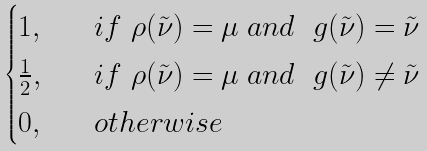<formula> <loc_0><loc_0><loc_500><loc_500>\begin{cases} 1 , \quad & i f \ \rho ( \tilde { \nu } ) = \mu \ a n d \ \ g ( \tilde { \nu } ) = \tilde { \nu } \\ \frac { 1 } { 2 } , \quad & i f \ \rho ( \tilde { \nu } ) = \mu \ a n d \ \ g ( \tilde { \nu } ) \neq \tilde { \nu } \\ 0 , & o t h e r w i s e \end{cases}</formula> 